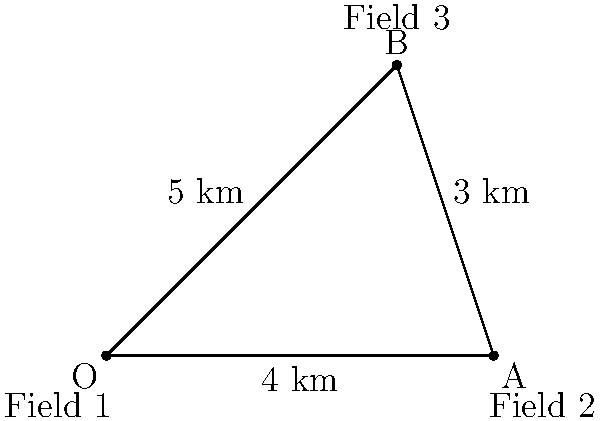Imagine you have three fields that need irrigation. The distance between Field 1 and Field 2 is 4 km, between Field 2 and Field 3 is 3 km, and between Field 1 and Field 3 is 5 km. If you want to dig a channel from Field 1 to Field 3 passing through Field 2, how much longer will this path be compared to digging a direct channel from Field 1 to Field 3? Let's break this down step-by-step:

1. In the diagram, we can see:
   - Field 1 is at point O
   - Field 2 is at point A
   - Field 3 is at point B

2. The distances given are:
   - O to A (Field 1 to Field 2): 4 km
   - A to B (Field 2 to Field 3): 3 km
   - O to B (Field 1 to Field 3): 5 km

3. To find how much longer the path O-A-B is compared to O-B:
   - Length of path O-A-B = OA + AB = 4 km + 3 km = 7 km
   - Length of direct path O-B = 5 km

4. The difference in length:
   7 km - 5 km = 2 km

So, the path from Field 1 to Field 3 passing through Field 2 is 2 km longer than the direct path.
Answer: 2 km 